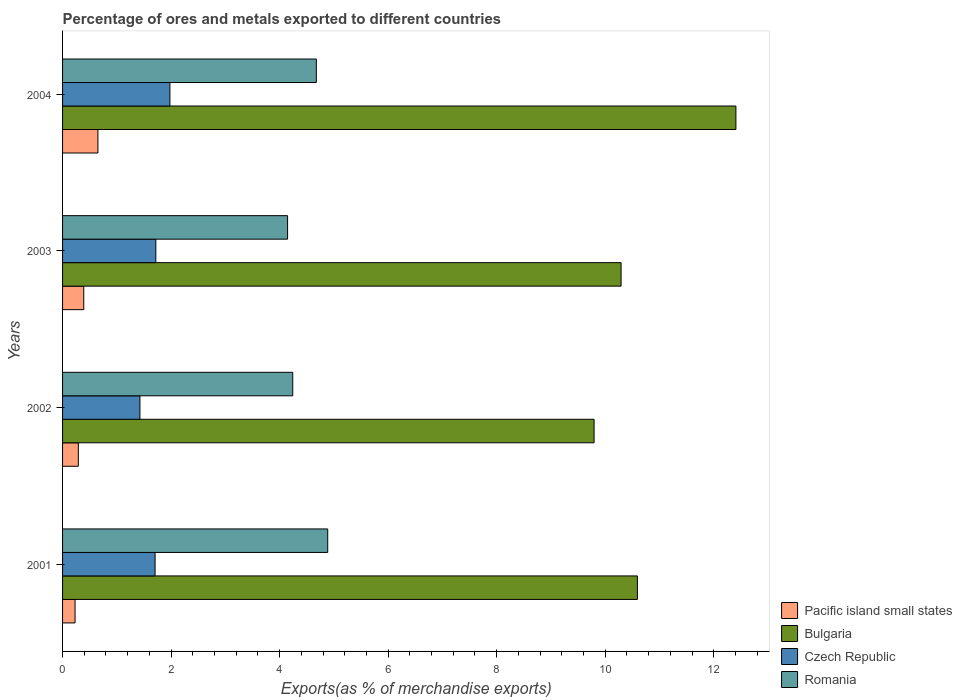How many different coloured bars are there?
Your answer should be compact. 4. Are the number of bars per tick equal to the number of legend labels?
Your answer should be very brief. Yes. Are the number of bars on each tick of the Y-axis equal?
Your response must be concise. Yes. How many bars are there on the 4th tick from the top?
Offer a very short reply. 4. What is the label of the 3rd group of bars from the top?
Provide a short and direct response. 2002. In how many cases, is the number of bars for a given year not equal to the number of legend labels?
Provide a succinct answer. 0. What is the percentage of exports to different countries in Pacific island small states in 2004?
Provide a short and direct response. 0.65. Across all years, what is the maximum percentage of exports to different countries in Romania?
Provide a short and direct response. 4.89. Across all years, what is the minimum percentage of exports to different countries in Romania?
Your response must be concise. 4.15. In which year was the percentage of exports to different countries in Romania maximum?
Make the answer very short. 2001. What is the total percentage of exports to different countries in Romania in the graph?
Make the answer very short. 17.95. What is the difference between the percentage of exports to different countries in Czech Republic in 2001 and that in 2004?
Offer a very short reply. -0.27. What is the difference between the percentage of exports to different countries in Romania in 2001 and the percentage of exports to different countries in Czech Republic in 2003?
Your answer should be very brief. 3.17. What is the average percentage of exports to different countries in Romania per year?
Your response must be concise. 4.49. In the year 2003, what is the difference between the percentage of exports to different countries in Bulgaria and percentage of exports to different countries in Pacific island small states?
Your answer should be very brief. 9.9. What is the ratio of the percentage of exports to different countries in Czech Republic in 2001 to that in 2004?
Give a very brief answer. 0.86. What is the difference between the highest and the second highest percentage of exports to different countries in Romania?
Your answer should be very brief. 0.21. What is the difference between the highest and the lowest percentage of exports to different countries in Pacific island small states?
Make the answer very short. 0.42. What does the 4th bar from the top in 2001 represents?
Your response must be concise. Pacific island small states. What does the 4th bar from the bottom in 2001 represents?
Offer a terse response. Romania. Is it the case that in every year, the sum of the percentage of exports to different countries in Pacific island small states and percentage of exports to different countries in Bulgaria is greater than the percentage of exports to different countries in Romania?
Provide a succinct answer. Yes. How many bars are there?
Provide a succinct answer. 16. Are all the bars in the graph horizontal?
Provide a succinct answer. Yes. How many years are there in the graph?
Offer a very short reply. 4. What is the difference between two consecutive major ticks on the X-axis?
Give a very brief answer. 2. Does the graph contain grids?
Make the answer very short. No. Where does the legend appear in the graph?
Your answer should be very brief. Bottom right. How are the legend labels stacked?
Make the answer very short. Vertical. What is the title of the graph?
Provide a succinct answer. Percentage of ores and metals exported to different countries. What is the label or title of the X-axis?
Offer a terse response. Exports(as % of merchandise exports). What is the Exports(as % of merchandise exports) in Pacific island small states in 2001?
Ensure brevity in your answer.  0.23. What is the Exports(as % of merchandise exports) of Bulgaria in 2001?
Make the answer very short. 10.59. What is the Exports(as % of merchandise exports) in Czech Republic in 2001?
Make the answer very short. 1.7. What is the Exports(as % of merchandise exports) of Romania in 2001?
Give a very brief answer. 4.89. What is the Exports(as % of merchandise exports) in Pacific island small states in 2002?
Make the answer very short. 0.29. What is the Exports(as % of merchandise exports) of Bulgaria in 2002?
Ensure brevity in your answer.  9.8. What is the Exports(as % of merchandise exports) of Czech Republic in 2002?
Ensure brevity in your answer.  1.43. What is the Exports(as % of merchandise exports) in Romania in 2002?
Your answer should be compact. 4.24. What is the Exports(as % of merchandise exports) of Pacific island small states in 2003?
Provide a succinct answer. 0.39. What is the Exports(as % of merchandise exports) of Bulgaria in 2003?
Offer a very short reply. 10.29. What is the Exports(as % of merchandise exports) in Czech Republic in 2003?
Give a very brief answer. 1.72. What is the Exports(as % of merchandise exports) of Romania in 2003?
Your answer should be very brief. 4.15. What is the Exports(as % of merchandise exports) of Pacific island small states in 2004?
Ensure brevity in your answer.  0.65. What is the Exports(as % of merchandise exports) of Bulgaria in 2004?
Provide a short and direct response. 12.41. What is the Exports(as % of merchandise exports) of Czech Republic in 2004?
Provide a succinct answer. 1.98. What is the Exports(as % of merchandise exports) in Romania in 2004?
Your answer should be compact. 4.68. Across all years, what is the maximum Exports(as % of merchandise exports) of Pacific island small states?
Provide a succinct answer. 0.65. Across all years, what is the maximum Exports(as % of merchandise exports) in Bulgaria?
Provide a succinct answer. 12.41. Across all years, what is the maximum Exports(as % of merchandise exports) of Czech Republic?
Your answer should be compact. 1.98. Across all years, what is the maximum Exports(as % of merchandise exports) of Romania?
Ensure brevity in your answer.  4.89. Across all years, what is the minimum Exports(as % of merchandise exports) of Pacific island small states?
Your answer should be very brief. 0.23. Across all years, what is the minimum Exports(as % of merchandise exports) in Bulgaria?
Give a very brief answer. 9.8. Across all years, what is the minimum Exports(as % of merchandise exports) in Czech Republic?
Offer a terse response. 1.43. Across all years, what is the minimum Exports(as % of merchandise exports) in Romania?
Make the answer very short. 4.15. What is the total Exports(as % of merchandise exports) in Pacific island small states in the graph?
Offer a terse response. 1.56. What is the total Exports(as % of merchandise exports) in Bulgaria in the graph?
Ensure brevity in your answer.  43.09. What is the total Exports(as % of merchandise exports) of Czech Republic in the graph?
Provide a short and direct response. 6.83. What is the total Exports(as % of merchandise exports) of Romania in the graph?
Ensure brevity in your answer.  17.95. What is the difference between the Exports(as % of merchandise exports) of Pacific island small states in 2001 and that in 2002?
Your response must be concise. -0.06. What is the difference between the Exports(as % of merchandise exports) in Bulgaria in 2001 and that in 2002?
Offer a terse response. 0.8. What is the difference between the Exports(as % of merchandise exports) of Czech Republic in 2001 and that in 2002?
Provide a short and direct response. 0.28. What is the difference between the Exports(as % of merchandise exports) in Romania in 2001 and that in 2002?
Your answer should be very brief. 0.64. What is the difference between the Exports(as % of merchandise exports) of Pacific island small states in 2001 and that in 2003?
Offer a terse response. -0.16. What is the difference between the Exports(as % of merchandise exports) in Bulgaria in 2001 and that in 2003?
Offer a very short reply. 0.3. What is the difference between the Exports(as % of merchandise exports) in Czech Republic in 2001 and that in 2003?
Provide a short and direct response. -0.01. What is the difference between the Exports(as % of merchandise exports) of Romania in 2001 and that in 2003?
Provide a succinct answer. 0.74. What is the difference between the Exports(as % of merchandise exports) in Pacific island small states in 2001 and that in 2004?
Your answer should be very brief. -0.42. What is the difference between the Exports(as % of merchandise exports) in Bulgaria in 2001 and that in 2004?
Your answer should be very brief. -1.82. What is the difference between the Exports(as % of merchandise exports) in Czech Republic in 2001 and that in 2004?
Your answer should be compact. -0.27. What is the difference between the Exports(as % of merchandise exports) in Romania in 2001 and that in 2004?
Keep it short and to the point. 0.21. What is the difference between the Exports(as % of merchandise exports) in Pacific island small states in 2002 and that in 2003?
Keep it short and to the point. -0.1. What is the difference between the Exports(as % of merchandise exports) in Bulgaria in 2002 and that in 2003?
Your answer should be very brief. -0.5. What is the difference between the Exports(as % of merchandise exports) of Czech Republic in 2002 and that in 2003?
Offer a very short reply. -0.29. What is the difference between the Exports(as % of merchandise exports) in Romania in 2002 and that in 2003?
Offer a very short reply. 0.1. What is the difference between the Exports(as % of merchandise exports) in Pacific island small states in 2002 and that in 2004?
Offer a very short reply. -0.36. What is the difference between the Exports(as % of merchandise exports) of Bulgaria in 2002 and that in 2004?
Make the answer very short. -2.61. What is the difference between the Exports(as % of merchandise exports) of Czech Republic in 2002 and that in 2004?
Offer a terse response. -0.55. What is the difference between the Exports(as % of merchandise exports) of Romania in 2002 and that in 2004?
Ensure brevity in your answer.  -0.43. What is the difference between the Exports(as % of merchandise exports) in Pacific island small states in 2003 and that in 2004?
Provide a short and direct response. -0.26. What is the difference between the Exports(as % of merchandise exports) in Bulgaria in 2003 and that in 2004?
Your response must be concise. -2.12. What is the difference between the Exports(as % of merchandise exports) of Czech Republic in 2003 and that in 2004?
Your answer should be very brief. -0.26. What is the difference between the Exports(as % of merchandise exports) of Romania in 2003 and that in 2004?
Provide a succinct answer. -0.53. What is the difference between the Exports(as % of merchandise exports) in Pacific island small states in 2001 and the Exports(as % of merchandise exports) in Bulgaria in 2002?
Provide a short and direct response. -9.56. What is the difference between the Exports(as % of merchandise exports) of Pacific island small states in 2001 and the Exports(as % of merchandise exports) of Czech Republic in 2002?
Keep it short and to the point. -1.2. What is the difference between the Exports(as % of merchandise exports) in Pacific island small states in 2001 and the Exports(as % of merchandise exports) in Romania in 2002?
Provide a succinct answer. -4.01. What is the difference between the Exports(as % of merchandise exports) in Bulgaria in 2001 and the Exports(as % of merchandise exports) in Czech Republic in 2002?
Provide a succinct answer. 9.17. What is the difference between the Exports(as % of merchandise exports) of Bulgaria in 2001 and the Exports(as % of merchandise exports) of Romania in 2002?
Ensure brevity in your answer.  6.35. What is the difference between the Exports(as % of merchandise exports) in Czech Republic in 2001 and the Exports(as % of merchandise exports) in Romania in 2002?
Offer a very short reply. -2.54. What is the difference between the Exports(as % of merchandise exports) of Pacific island small states in 2001 and the Exports(as % of merchandise exports) of Bulgaria in 2003?
Keep it short and to the point. -10.06. What is the difference between the Exports(as % of merchandise exports) of Pacific island small states in 2001 and the Exports(as % of merchandise exports) of Czech Republic in 2003?
Provide a succinct answer. -1.49. What is the difference between the Exports(as % of merchandise exports) in Pacific island small states in 2001 and the Exports(as % of merchandise exports) in Romania in 2003?
Keep it short and to the point. -3.92. What is the difference between the Exports(as % of merchandise exports) of Bulgaria in 2001 and the Exports(as % of merchandise exports) of Czech Republic in 2003?
Your answer should be compact. 8.87. What is the difference between the Exports(as % of merchandise exports) in Bulgaria in 2001 and the Exports(as % of merchandise exports) in Romania in 2003?
Your answer should be compact. 6.45. What is the difference between the Exports(as % of merchandise exports) of Czech Republic in 2001 and the Exports(as % of merchandise exports) of Romania in 2003?
Your response must be concise. -2.44. What is the difference between the Exports(as % of merchandise exports) in Pacific island small states in 2001 and the Exports(as % of merchandise exports) in Bulgaria in 2004?
Your response must be concise. -12.18. What is the difference between the Exports(as % of merchandise exports) in Pacific island small states in 2001 and the Exports(as % of merchandise exports) in Czech Republic in 2004?
Make the answer very short. -1.75. What is the difference between the Exports(as % of merchandise exports) in Pacific island small states in 2001 and the Exports(as % of merchandise exports) in Romania in 2004?
Give a very brief answer. -4.45. What is the difference between the Exports(as % of merchandise exports) of Bulgaria in 2001 and the Exports(as % of merchandise exports) of Czech Republic in 2004?
Keep it short and to the point. 8.61. What is the difference between the Exports(as % of merchandise exports) in Bulgaria in 2001 and the Exports(as % of merchandise exports) in Romania in 2004?
Provide a short and direct response. 5.92. What is the difference between the Exports(as % of merchandise exports) in Czech Republic in 2001 and the Exports(as % of merchandise exports) in Romania in 2004?
Provide a short and direct response. -2.97. What is the difference between the Exports(as % of merchandise exports) in Pacific island small states in 2002 and the Exports(as % of merchandise exports) in Bulgaria in 2003?
Ensure brevity in your answer.  -10. What is the difference between the Exports(as % of merchandise exports) in Pacific island small states in 2002 and the Exports(as % of merchandise exports) in Czech Republic in 2003?
Give a very brief answer. -1.43. What is the difference between the Exports(as % of merchandise exports) of Pacific island small states in 2002 and the Exports(as % of merchandise exports) of Romania in 2003?
Offer a terse response. -3.86. What is the difference between the Exports(as % of merchandise exports) of Bulgaria in 2002 and the Exports(as % of merchandise exports) of Czech Republic in 2003?
Ensure brevity in your answer.  8.08. What is the difference between the Exports(as % of merchandise exports) of Bulgaria in 2002 and the Exports(as % of merchandise exports) of Romania in 2003?
Your answer should be very brief. 5.65. What is the difference between the Exports(as % of merchandise exports) in Czech Republic in 2002 and the Exports(as % of merchandise exports) in Romania in 2003?
Provide a short and direct response. -2.72. What is the difference between the Exports(as % of merchandise exports) in Pacific island small states in 2002 and the Exports(as % of merchandise exports) in Bulgaria in 2004?
Offer a very short reply. -12.12. What is the difference between the Exports(as % of merchandise exports) of Pacific island small states in 2002 and the Exports(as % of merchandise exports) of Czech Republic in 2004?
Make the answer very short. -1.69. What is the difference between the Exports(as % of merchandise exports) in Pacific island small states in 2002 and the Exports(as % of merchandise exports) in Romania in 2004?
Offer a terse response. -4.39. What is the difference between the Exports(as % of merchandise exports) in Bulgaria in 2002 and the Exports(as % of merchandise exports) in Czech Republic in 2004?
Your response must be concise. 7.82. What is the difference between the Exports(as % of merchandise exports) in Bulgaria in 2002 and the Exports(as % of merchandise exports) in Romania in 2004?
Ensure brevity in your answer.  5.12. What is the difference between the Exports(as % of merchandise exports) in Czech Republic in 2002 and the Exports(as % of merchandise exports) in Romania in 2004?
Your response must be concise. -3.25. What is the difference between the Exports(as % of merchandise exports) of Pacific island small states in 2003 and the Exports(as % of merchandise exports) of Bulgaria in 2004?
Your response must be concise. -12.02. What is the difference between the Exports(as % of merchandise exports) in Pacific island small states in 2003 and the Exports(as % of merchandise exports) in Czech Republic in 2004?
Offer a very short reply. -1.59. What is the difference between the Exports(as % of merchandise exports) of Pacific island small states in 2003 and the Exports(as % of merchandise exports) of Romania in 2004?
Provide a short and direct response. -4.29. What is the difference between the Exports(as % of merchandise exports) of Bulgaria in 2003 and the Exports(as % of merchandise exports) of Czech Republic in 2004?
Provide a succinct answer. 8.31. What is the difference between the Exports(as % of merchandise exports) of Bulgaria in 2003 and the Exports(as % of merchandise exports) of Romania in 2004?
Provide a succinct answer. 5.62. What is the difference between the Exports(as % of merchandise exports) in Czech Republic in 2003 and the Exports(as % of merchandise exports) in Romania in 2004?
Offer a terse response. -2.96. What is the average Exports(as % of merchandise exports) in Pacific island small states per year?
Your response must be concise. 0.39. What is the average Exports(as % of merchandise exports) of Bulgaria per year?
Offer a very short reply. 10.77. What is the average Exports(as % of merchandise exports) of Czech Republic per year?
Keep it short and to the point. 1.71. What is the average Exports(as % of merchandise exports) in Romania per year?
Offer a terse response. 4.49. In the year 2001, what is the difference between the Exports(as % of merchandise exports) of Pacific island small states and Exports(as % of merchandise exports) of Bulgaria?
Offer a very short reply. -10.36. In the year 2001, what is the difference between the Exports(as % of merchandise exports) of Pacific island small states and Exports(as % of merchandise exports) of Czech Republic?
Offer a terse response. -1.47. In the year 2001, what is the difference between the Exports(as % of merchandise exports) of Pacific island small states and Exports(as % of merchandise exports) of Romania?
Give a very brief answer. -4.66. In the year 2001, what is the difference between the Exports(as % of merchandise exports) of Bulgaria and Exports(as % of merchandise exports) of Czech Republic?
Your answer should be compact. 8.89. In the year 2001, what is the difference between the Exports(as % of merchandise exports) of Bulgaria and Exports(as % of merchandise exports) of Romania?
Your answer should be very brief. 5.71. In the year 2001, what is the difference between the Exports(as % of merchandise exports) of Czech Republic and Exports(as % of merchandise exports) of Romania?
Keep it short and to the point. -3.18. In the year 2002, what is the difference between the Exports(as % of merchandise exports) of Pacific island small states and Exports(as % of merchandise exports) of Bulgaria?
Provide a short and direct response. -9.5. In the year 2002, what is the difference between the Exports(as % of merchandise exports) of Pacific island small states and Exports(as % of merchandise exports) of Czech Republic?
Make the answer very short. -1.14. In the year 2002, what is the difference between the Exports(as % of merchandise exports) in Pacific island small states and Exports(as % of merchandise exports) in Romania?
Provide a succinct answer. -3.95. In the year 2002, what is the difference between the Exports(as % of merchandise exports) of Bulgaria and Exports(as % of merchandise exports) of Czech Republic?
Make the answer very short. 8.37. In the year 2002, what is the difference between the Exports(as % of merchandise exports) in Bulgaria and Exports(as % of merchandise exports) in Romania?
Your response must be concise. 5.55. In the year 2002, what is the difference between the Exports(as % of merchandise exports) in Czech Republic and Exports(as % of merchandise exports) in Romania?
Ensure brevity in your answer.  -2.82. In the year 2003, what is the difference between the Exports(as % of merchandise exports) of Pacific island small states and Exports(as % of merchandise exports) of Bulgaria?
Keep it short and to the point. -9.9. In the year 2003, what is the difference between the Exports(as % of merchandise exports) of Pacific island small states and Exports(as % of merchandise exports) of Czech Republic?
Provide a succinct answer. -1.33. In the year 2003, what is the difference between the Exports(as % of merchandise exports) in Pacific island small states and Exports(as % of merchandise exports) in Romania?
Your answer should be very brief. -3.76. In the year 2003, what is the difference between the Exports(as % of merchandise exports) of Bulgaria and Exports(as % of merchandise exports) of Czech Republic?
Make the answer very short. 8.57. In the year 2003, what is the difference between the Exports(as % of merchandise exports) of Bulgaria and Exports(as % of merchandise exports) of Romania?
Provide a succinct answer. 6.15. In the year 2003, what is the difference between the Exports(as % of merchandise exports) in Czech Republic and Exports(as % of merchandise exports) in Romania?
Your answer should be compact. -2.43. In the year 2004, what is the difference between the Exports(as % of merchandise exports) in Pacific island small states and Exports(as % of merchandise exports) in Bulgaria?
Offer a terse response. -11.76. In the year 2004, what is the difference between the Exports(as % of merchandise exports) in Pacific island small states and Exports(as % of merchandise exports) in Czech Republic?
Ensure brevity in your answer.  -1.33. In the year 2004, what is the difference between the Exports(as % of merchandise exports) of Pacific island small states and Exports(as % of merchandise exports) of Romania?
Provide a short and direct response. -4.03. In the year 2004, what is the difference between the Exports(as % of merchandise exports) of Bulgaria and Exports(as % of merchandise exports) of Czech Republic?
Keep it short and to the point. 10.43. In the year 2004, what is the difference between the Exports(as % of merchandise exports) in Bulgaria and Exports(as % of merchandise exports) in Romania?
Give a very brief answer. 7.73. In the year 2004, what is the difference between the Exports(as % of merchandise exports) in Czech Republic and Exports(as % of merchandise exports) in Romania?
Your response must be concise. -2.7. What is the ratio of the Exports(as % of merchandise exports) of Pacific island small states in 2001 to that in 2002?
Your response must be concise. 0.79. What is the ratio of the Exports(as % of merchandise exports) of Bulgaria in 2001 to that in 2002?
Provide a succinct answer. 1.08. What is the ratio of the Exports(as % of merchandise exports) of Czech Republic in 2001 to that in 2002?
Your answer should be very brief. 1.2. What is the ratio of the Exports(as % of merchandise exports) in Romania in 2001 to that in 2002?
Your response must be concise. 1.15. What is the ratio of the Exports(as % of merchandise exports) in Pacific island small states in 2001 to that in 2003?
Offer a very short reply. 0.59. What is the ratio of the Exports(as % of merchandise exports) of Bulgaria in 2001 to that in 2003?
Your response must be concise. 1.03. What is the ratio of the Exports(as % of merchandise exports) of Czech Republic in 2001 to that in 2003?
Provide a succinct answer. 0.99. What is the ratio of the Exports(as % of merchandise exports) of Romania in 2001 to that in 2003?
Offer a terse response. 1.18. What is the ratio of the Exports(as % of merchandise exports) of Pacific island small states in 2001 to that in 2004?
Keep it short and to the point. 0.35. What is the ratio of the Exports(as % of merchandise exports) of Bulgaria in 2001 to that in 2004?
Keep it short and to the point. 0.85. What is the ratio of the Exports(as % of merchandise exports) of Czech Republic in 2001 to that in 2004?
Offer a terse response. 0.86. What is the ratio of the Exports(as % of merchandise exports) in Romania in 2001 to that in 2004?
Your answer should be very brief. 1.04. What is the ratio of the Exports(as % of merchandise exports) in Pacific island small states in 2002 to that in 2003?
Keep it short and to the point. 0.74. What is the ratio of the Exports(as % of merchandise exports) of Bulgaria in 2002 to that in 2003?
Give a very brief answer. 0.95. What is the ratio of the Exports(as % of merchandise exports) in Czech Republic in 2002 to that in 2003?
Your answer should be compact. 0.83. What is the ratio of the Exports(as % of merchandise exports) in Pacific island small states in 2002 to that in 2004?
Provide a succinct answer. 0.45. What is the ratio of the Exports(as % of merchandise exports) in Bulgaria in 2002 to that in 2004?
Ensure brevity in your answer.  0.79. What is the ratio of the Exports(as % of merchandise exports) of Czech Republic in 2002 to that in 2004?
Make the answer very short. 0.72. What is the ratio of the Exports(as % of merchandise exports) of Romania in 2002 to that in 2004?
Provide a succinct answer. 0.91. What is the ratio of the Exports(as % of merchandise exports) in Pacific island small states in 2003 to that in 2004?
Provide a succinct answer. 0.6. What is the ratio of the Exports(as % of merchandise exports) in Bulgaria in 2003 to that in 2004?
Keep it short and to the point. 0.83. What is the ratio of the Exports(as % of merchandise exports) in Czech Republic in 2003 to that in 2004?
Provide a succinct answer. 0.87. What is the ratio of the Exports(as % of merchandise exports) of Romania in 2003 to that in 2004?
Provide a short and direct response. 0.89. What is the difference between the highest and the second highest Exports(as % of merchandise exports) of Pacific island small states?
Ensure brevity in your answer.  0.26. What is the difference between the highest and the second highest Exports(as % of merchandise exports) of Bulgaria?
Your response must be concise. 1.82. What is the difference between the highest and the second highest Exports(as % of merchandise exports) of Czech Republic?
Your answer should be very brief. 0.26. What is the difference between the highest and the second highest Exports(as % of merchandise exports) in Romania?
Ensure brevity in your answer.  0.21. What is the difference between the highest and the lowest Exports(as % of merchandise exports) of Pacific island small states?
Give a very brief answer. 0.42. What is the difference between the highest and the lowest Exports(as % of merchandise exports) of Bulgaria?
Your answer should be compact. 2.61. What is the difference between the highest and the lowest Exports(as % of merchandise exports) in Czech Republic?
Keep it short and to the point. 0.55. What is the difference between the highest and the lowest Exports(as % of merchandise exports) in Romania?
Keep it short and to the point. 0.74. 